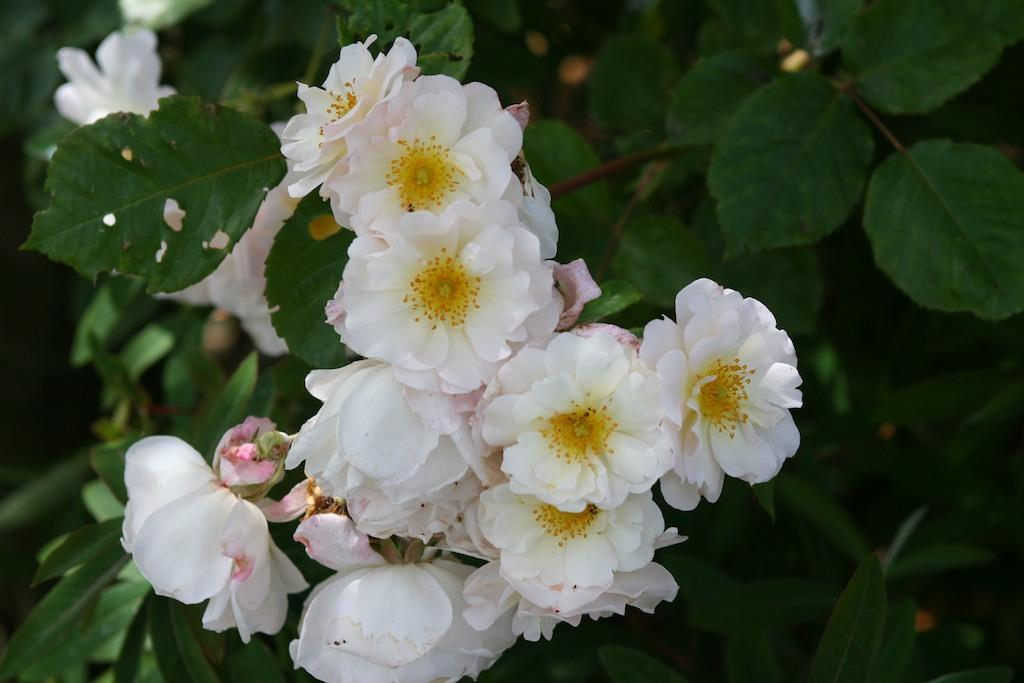What type of plant is featured in the image? There is a plant with flowers in the image. What color are the flowers on the plant? The flowers are white. What can be seen in the background of the image? There are plants or trees in the background of the image. How does the plant crush the other plants in the image? The plant does not crush any other plants in the image; it is simply a plant with flowers. 